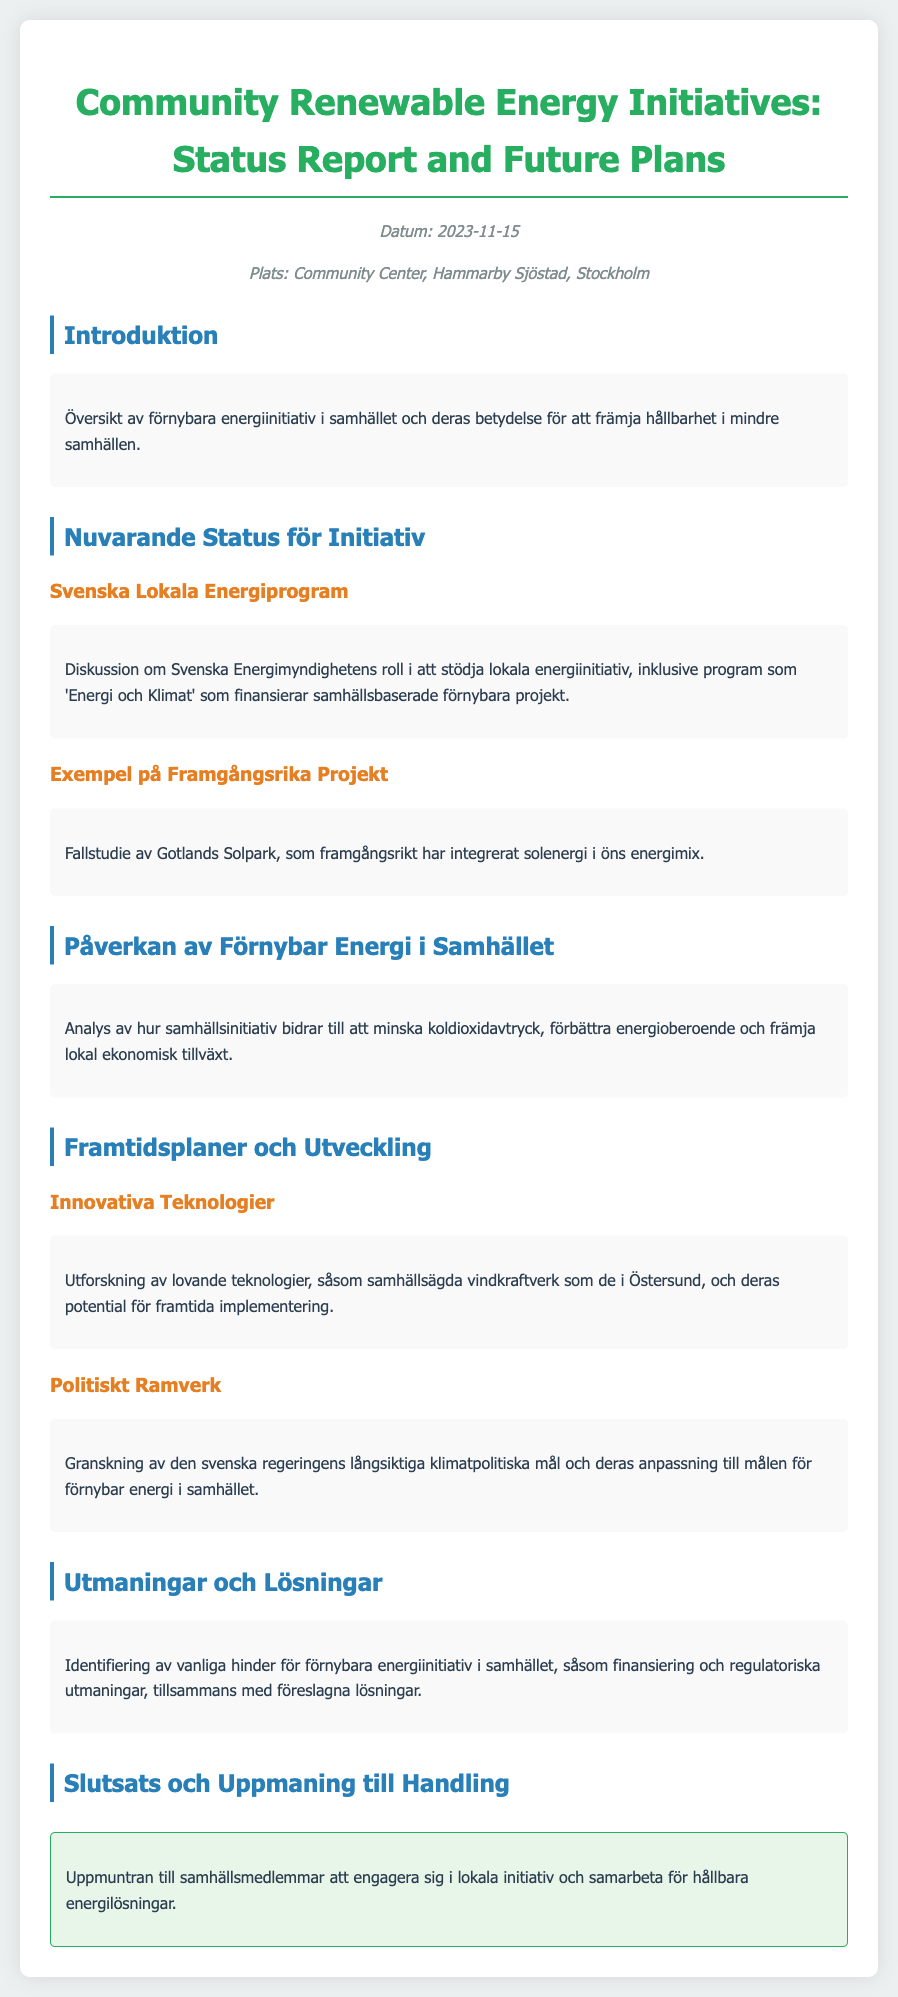Vad är datumet för mötet? Datumet anges i dokumentet som den 15 november 2023.
Answer: 2023-11-15 Var hålls mötet? Platsen för mötet är angiven i dokumentet som Hammarby Sjöstad, Stockholm.
Answer: Hammarby Sjöstad, Stockholm Vilket program stöder lokala energiinitiativ? Programmet som stöder lokala energiinitiativ kallas 'Energi och Klimat'.
Answer: Energi och Klimat Vilken typ av energi integreras i Gotlands Solpark? Dokumentet nämner att Gotlands Solpark framgångsrikt har integrerat solenergi.
Answer: Solenergi Vad är en av de föreslagna lösningarna för utmaningar inom förnybar energi? Dokumentet diskuterar vanliga hinder för förnybara energiinvesteringar, men ger inte specifika lösningar. En av lösningarna kommenteras allmänt.
Answer: Finansiering Vilken teknologi ges som exempel för framtida utveckling? Exemplet på innovativ teknologi som nämns är samhällsägda vindkraftverk.
Answer: Samhällsägda vindkraftverk Vad uppmanas samhällsmedlemmar att göra i slutsatsen? I slutsatsen uppmanas samhällsmedlemmar att engagera sig i lokala initiativ.
Answer: Engagera sig i lokala initiativ Vilken myndighet nämns i samband med lokala energiinitiativ? Myndigheten som diskuteras i dokumentet är Svenska Energimyndigheten.
Answer: Svenska Energimyndigheten Hur bidrar samhällsinitiativ enligt dokumentet? Dokumentet beskriver hur samhällsinitiativ bidrar till att minska koldioxidavtryck.
Answer: Minska koldioxidavtryck 